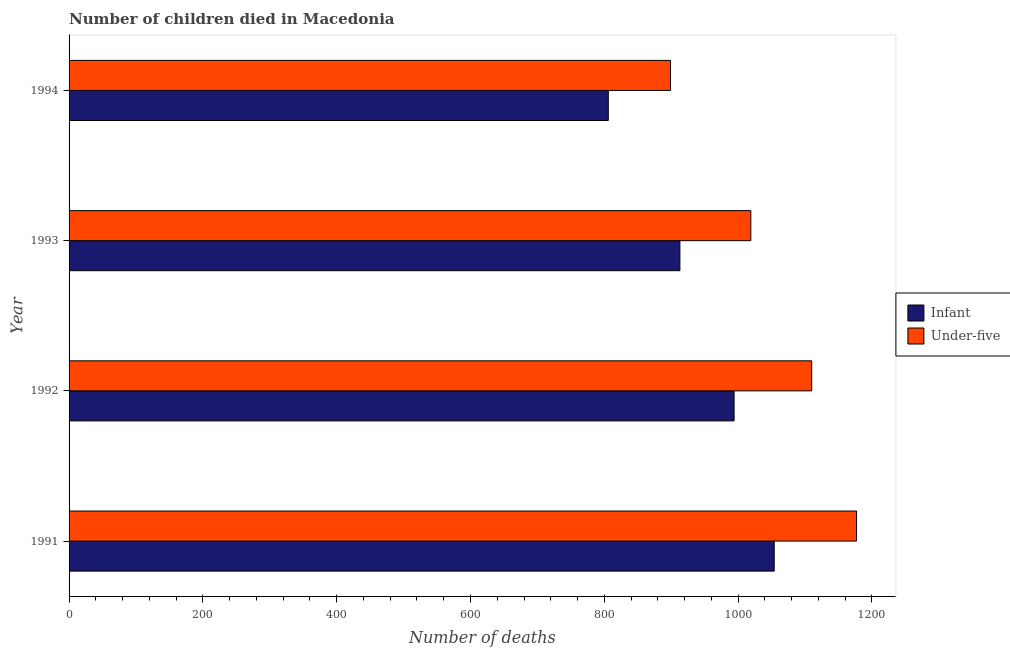How many groups of bars are there?
Give a very brief answer. 4. Are the number of bars on each tick of the Y-axis equal?
Provide a short and direct response. Yes. What is the number of under-five deaths in 1992?
Your response must be concise. 1110. Across all years, what is the maximum number of under-five deaths?
Your response must be concise. 1177. Across all years, what is the minimum number of infant deaths?
Your response must be concise. 806. In which year was the number of infant deaths maximum?
Your response must be concise. 1991. In which year was the number of under-five deaths minimum?
Provide a short and direct response. 1994. What is the total number of under-five deaths in the graph?
Ensure brevity in your answer.  4205. What is the difference between the number of infant deaths in 1991 and that in 1994?
Keep it short and to the point. 248. What is the difference between the number of infant deaths in 1992 and the number of under-five deaths in 1993?
Give a very brief answer. -25. What is the average number of infant deaths per year?
Provide a succinct answer. 941.75. In the year 1993, what is the difference between the number of infant deaths and number of under-five deaths?
Give a very brief answer. -106. In how many years, is the number of under-five deaths greater than 720 ?
Keep it short and to the point. 4. What is the ratio of the number of under-five deaths in 1992 to that in 1993?
Your answer should be compact. 1.09. Is the number of under-five deaths in 1993 less than that in 1994?
Make the answer very short. No. Is the difference between the number of under-five deaths in 1992 and 1994 greater than the difference between the number of infant deaths in 1992 and 1994?
Offer a terse response. Yes. What is the difference between the highest and the second highest number of under-five deaths?
Provide a short and direct response. 67. What is the difference between the highest and the lowest number of infant deaths?
Your answer should be compact. 248. In how many years, is the number of infant deaths greater than the average number of infant deaths taken over all years?
Provide a succinct answer. 2. What does the 2nd bar from the top in 1993 represents?
Give a very brief answer. Infant. What does the 2nd bar from the bottom in 1992 represents?
Give a very brief answer. Under-five. How many bars are there?
Offer a very short reply. 8. Are all the bars in the graph horizontal?
Your answer should be compact. Yes. Are the values on the major ticks of X-axis written in scientific E-notation?
Keep it short and to the point. No. Does the graph contain grids?
Your answer should be very brief. No. How many legend labels are there?
Give a very brief answer. 2. What is the title of the graph?
Ensure brevity in your answer.  Number of children died in Macedonia. Does "External balance on goods" appear as one of the legend labels in the graph?
Your answer should be very brief. No. What is the label or title of the X-axis?
Give a very brief answer. Number of deaths. What is the label or title of the Y-axis?
Your response must be concise. Year. What is the Number of deaths in Infant in 1991?
Your response must be concise. 1054. What is the Number of deaths in Under-five in 1991?
Offer a very short reply. 1177. What is the Number of deaths in Infant in 1992?
Keep it short and to the point. 994. What is the Number of deaths in Under-five in 1992?
Your answer should be compact. 1110. What is the Number of deaths in Infant in 1993?
Your answer should be compact. 913. What is the Number of deaths of Under-five in 1993?
Keep it short and to the point. 1019. What is the Number of deaths in Infant in 1994?
Ensure brevity in your answer.  806. What is the Number of deaths of Under-five in 1994?
Your answer should be very brief. 899. Across all years, what is the maximum Number of deaths in Infant?
Offer a very short reply. 1054. Across all years, what is the maximum Number of deaths of Under-five?
Ensure brevity in your answer.  1177. Across all years, what is the minimum Number of deaths in Infant?
Offer a very short reply. 806. Across all years, what is the minimum Number of deaths in Under-five?
Your response must be concise. 899. What is the total Number of deaths of Infant in the graph?
Give a very brief answer. 3767. What is the total Number of deaths in Under-five in the graph?
Offer a very short reply. 4205. What is the difference between the Number of deaths of Infant in 1991 and that in 1993?
Keep it short and to the point. 141. What is the difference between the Number of deaths of Under-five in 1991 and that in 1993?
Your answer should be very brief. 158. What is the difference between the Number of deaths in Infant in 1991 and that in 1994?
Give a very brief answer. 248. What is the difference between the Number of deaths in Under-five in 1991 and that in 1994?
Make the answer very short. 278. What is the difference between the Number of deaths in Under-five in 1992 and that in 1993?
Offer a very short reply. 91. What is the difference between the Number of deaths in Infant in 1992 and that in 1994?
Your answer should be compact. 188. What is the difference between the Number of deaths of Under-five in 1992 and that in 1994?
Offer a very short reply. 211. What is the difference between the Number of deaths of Infant in 1993 and that in 1994?
Make the answer very short. 107. What is the difference between the Number of deaths in Under-five in 1993 and that in 1994?
Your answer should be very brief. 120. What is the difference between the Number of deaths of Infant in 1991 and the Number of deaths of Under-five in 1992?
Provide a short and direct response. -56. What is the difference between the Number of deaths in Infant in 1991 and the Number of deaths in Under-five in 1994?
Provide a succinct answer. 155. What is the difference between the Number of deaths in Infant in 1992 and the Number of deaths in Under-five in 1994?
Your answer should be very brief. 95. What is the average Number of deaths in Infant per year?
Keep it short and to the point. 941.75. What is the average Number of deaths in Under-five per year?
Your answer should be very brief. 1051.25. In the year 1991, what is the difference between the Number of deaths in Infant and Number of deaths in Under-five?
Keep it short and to the point. -123. In the year 1992, what is the difference between the Number of deaths in Infant and Number of deaths in Under-five?
Give a very brief answer. -116. In the year 1993, what is the difference between the Number of deaths of Infant and Number of deaths of Under-five?
Keep it short and to the point. -106. In the year 1994, what is the difference between the Number of deaths in Infant and Number of deaths in Under-five?
Your answer should be very brief. -93. What is the ratio of the Number of deaths in Infant in 1991 to that in 1992?
Keep it short and to the point. 1.06. What is the ratio of the Number of deaths in Under-five in 1991 to that in 1992?
Make the answer very short. 1.06. What is the ratio of the Number of deaths of Infant in 1991 to that in 1993?
Your response must be concise. 1.15. What is the ratio of the Number of deaths of Under-five in 1991 to that in 1993?
Offer a very short reply. 1.16. What is the ratio of the Number of deaths of Infant in 1991 to that in 1994?
Offer a terse response. 1.31. What is the ratio of the Number of deaths of Under-five in 1991 to that in 1994?
Provide a succinct answer. 1.31. What is the ratio of the Number of deaths in Infant in 1992 to that in 1993?
Offer a very short reply. 1.09. What is the ratio of the Number of deaths in Under-five in 1992 to that in 1993?
Offer a very short reply. 1.09. What is the ratio of the Number of deaths in Infant in 1992 to that in 1994?
Your answer should be very brief. 1.23. What is the ratio of the Number of deaths of Under-five in 1992 to that in 1994?
Provide a short and direct response. 1.23. What is the ratio of the Number of deaths of Infant in 1993 to that in 1994?
Offer a very short reply. 1.13. What is the ratio of the Number of deaths in Under-five in 1993 to that in 1994?
Offer a terse response. 1.13. What is the difference between the highest and the second highest Number of deaths in Infant?
Your answer should be compact. 60. What is the difference between the highest and the second highest Number of deaths in Under-five?
Make the answer very short. 67. What is the difference between the highest and the lowest Number of deaths in Infant?
Make the answer very short. 248. What is the difference between the highest and the lowest Number of deaths in Under-five?
Ensure brevity in your answer.  278. 